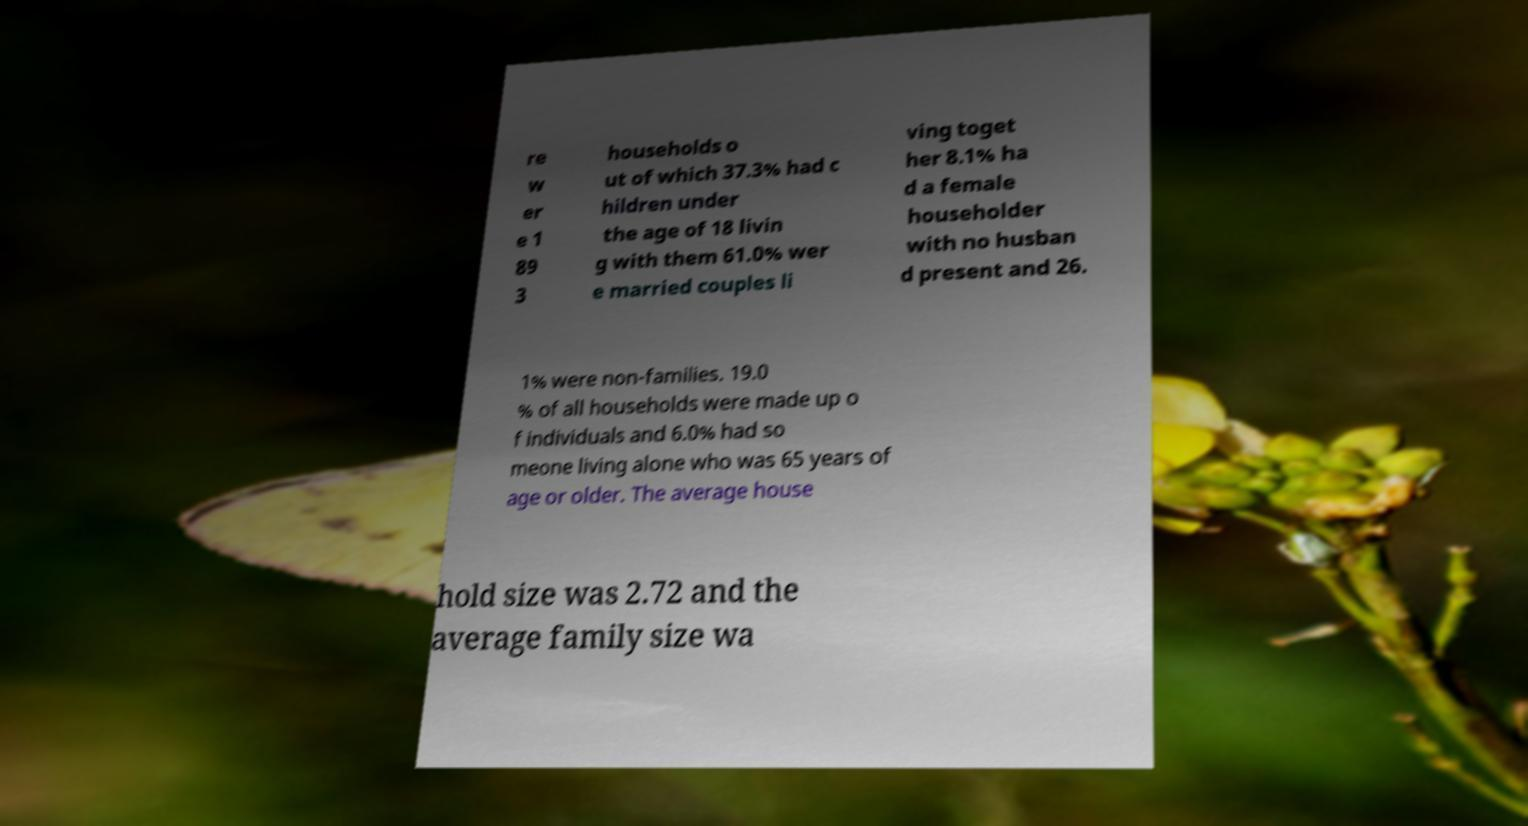Please identify and transcribe the text found in this image. re w er e 1 89 3 households o ut of which 37.3% had c hildren under the age of 18 livin g with them 61.0% wer e married couples li ving toget her 8.1% ha d a female householder with no husban d present and 26. 1% were non-families. 19.0 % of all households were made up o f individuals and 6.0% had so meone living alone who was 65 years of age or older. The average house hold size was 2.72 and the average family size wa 